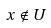Convert formula to latex. <formula><loc_0><loc_0><loc_500><loc_500>x \notin U</formula> 